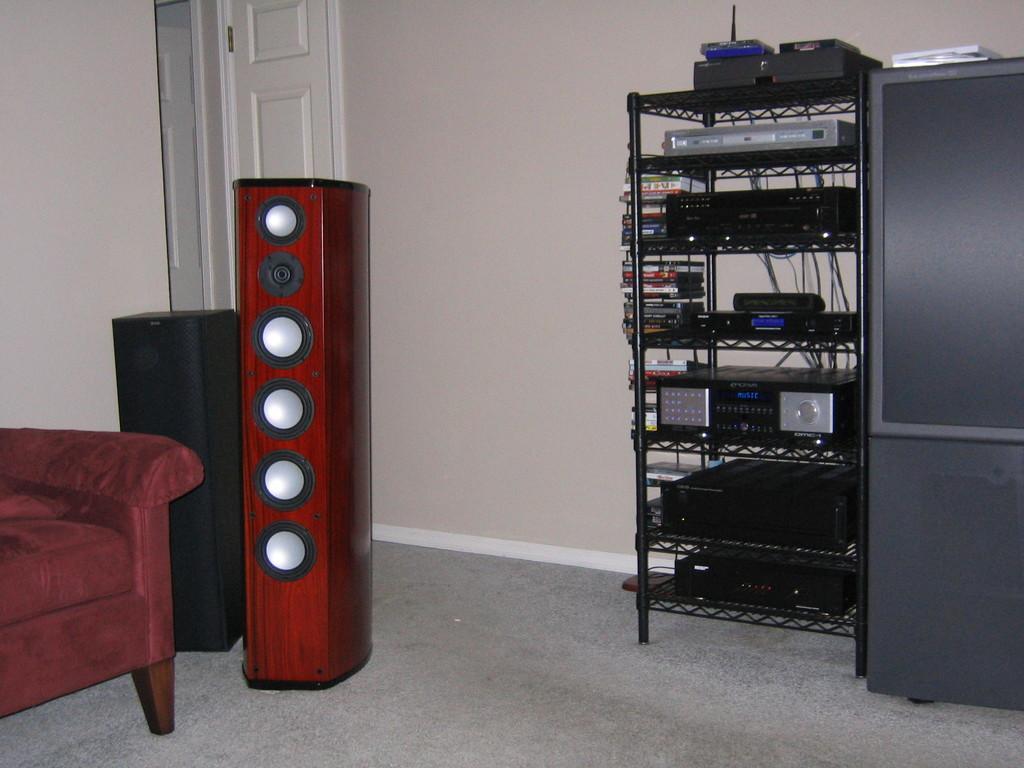How would you summarize this image in a sentence or two? In the image we can see shelf. In shelf we can see CD's,recorder and some electronics,speakers,couch,door and few more objects. 